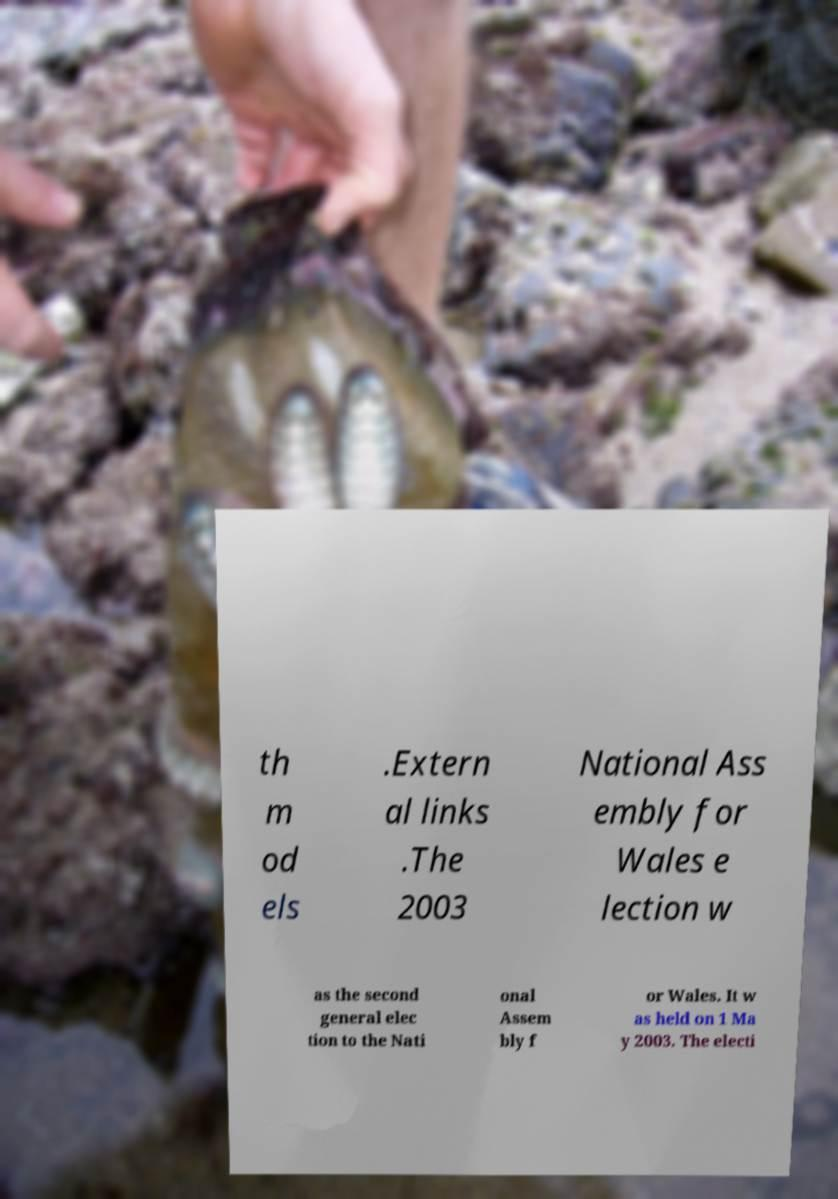For documentation purposes, I need the text within this image transcribed. Could you provide that? th m od els .Extern al links .The 2003 National Ass embly for Wales e lection w as the second general elec tion to the Nati onal Assem bly f or Wales. It w as held on 1 Ma y 2003. The electi 